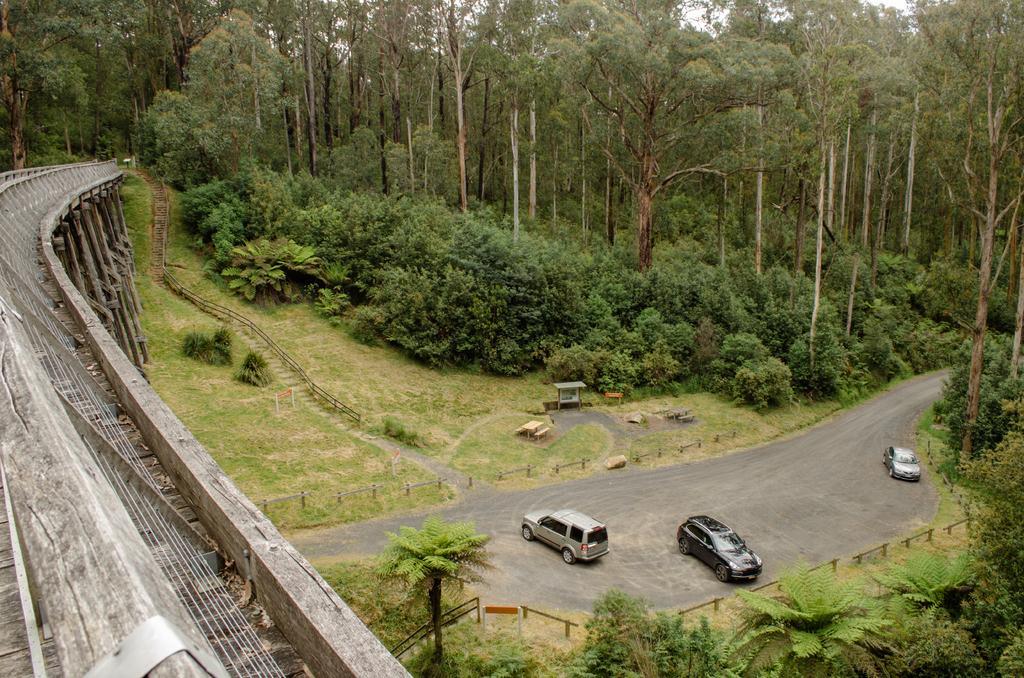How would you summarize this image in a sentence or two? On the left side of the image there is a bridge. At the bottom there are cars on the road and we can see a fence. In the background there are trees, stairs and sky. 